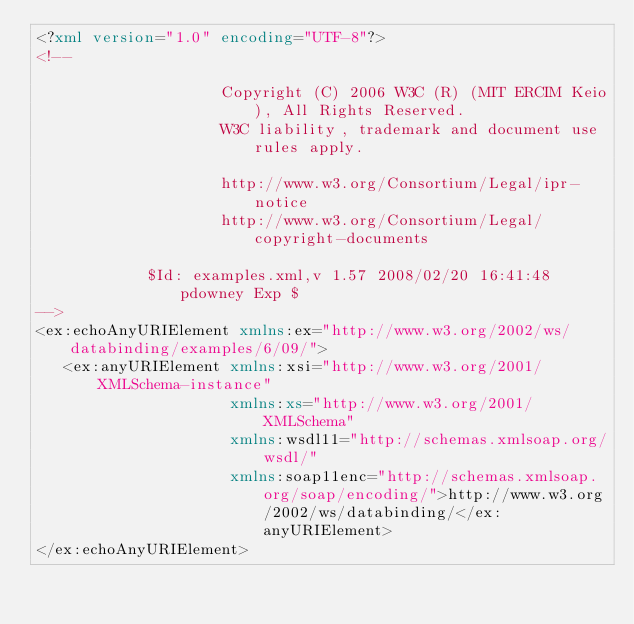<code> <loc_0><loc_0><loc_500><loc_500><_XML_><?xml version="1.0" encoding="UTF-8"?>
<!--
                    
                    Copyright (C) 2006 W3C (R) (MIT ERCIM Keio), All Rights Reserved.
                    W3C liability, trademark and document use rules apply.
                    
                    http://www.w3.org/Consortium/Legal/ipr-notice
                    http://www.w3.org/Consortium/Legal/copyright-documents
                    
		    $Id: examples.xml,v 1.57 2008/02/20 16:41:48 pdowney Exp $
-->
<ex:echoAnyURIElement xmlns:ex="http://www.w3.org/2002/ws/databinding/examples/6/09/">
   <ex:anyURIElement xmlns:xsi="http://www.w3.org/2001/XMLSchema-instance"
                     xmlns:xs="http://www.w3.org/2001/XMLSchema"
                     xmlns:wsdl11="http://schemas.xmlsoap.org/wsdl/"
                     xmlns:soap11enc="http://schemas.xmlsoap.org/soap/encoding/">http://www.w3.org/2002/ws/databinding/</ex:anyURIElement>
</ex:echoAnyURIElement></code> 